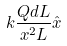Convert formula to latex. <formula><loc_0><loc_0><loc_500><loc_500>k \frac { Q d L } { x ^ { 2 } L } \hat { x }</formula> 